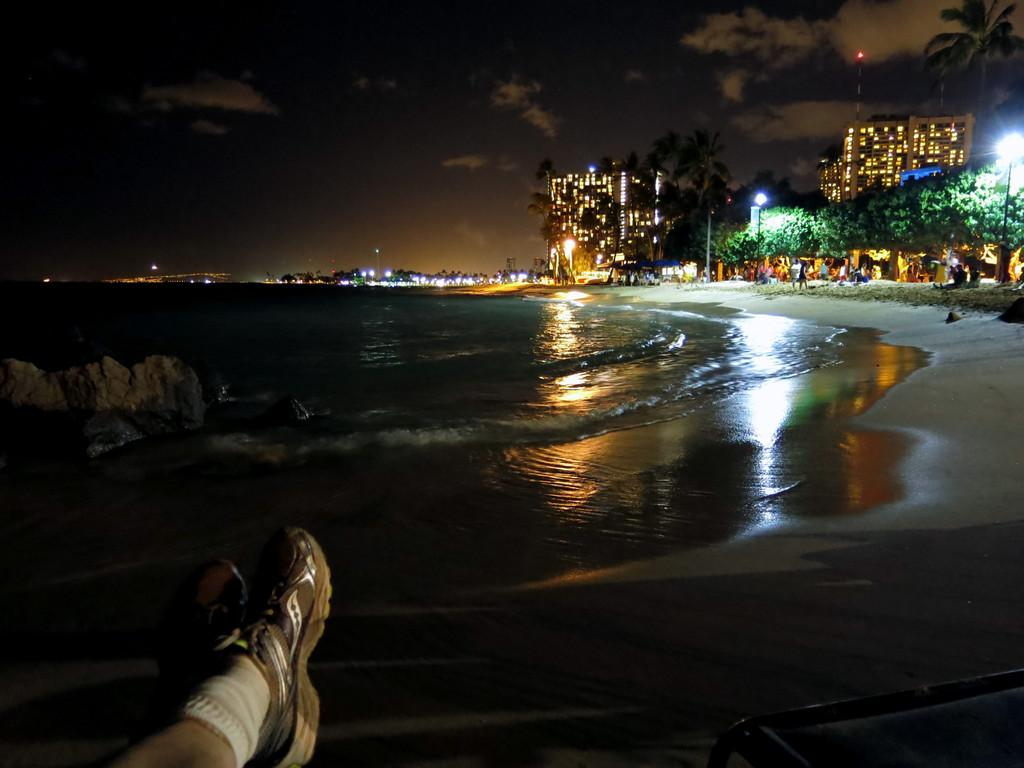What is the primary element visible in the image? There is water in the image. Can you describe the people in the image? There are people in the image. What type of terrain is present in the image? There is sand in the image. What structures can be seen in the image? There are buildings in the image. What type of vegetation is present in the image? There are trees in the image. What is visible in the sky in the image? The sky is visible in the image, and clouds are present. How would you describe the lighting in the image? The image is slightly dark. What type of fan is visible in the image? There is no fan present in the image. Can you describe the cork in the image? There is no cork present in the image. 